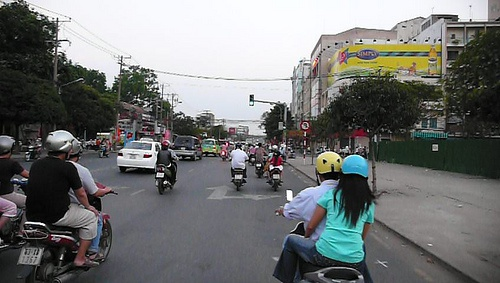Describe the objects in this image and their specific colors. I can see people in darkgray, black, turquoise, and teal tones, people in darkgray, black, gray, and maroon tones, motorcycle in darkgray, black, gray, and maroon tones, people in darkgray, black, and lavender tones, and people in darkgray, black, gray, and maroon tones in this image. 